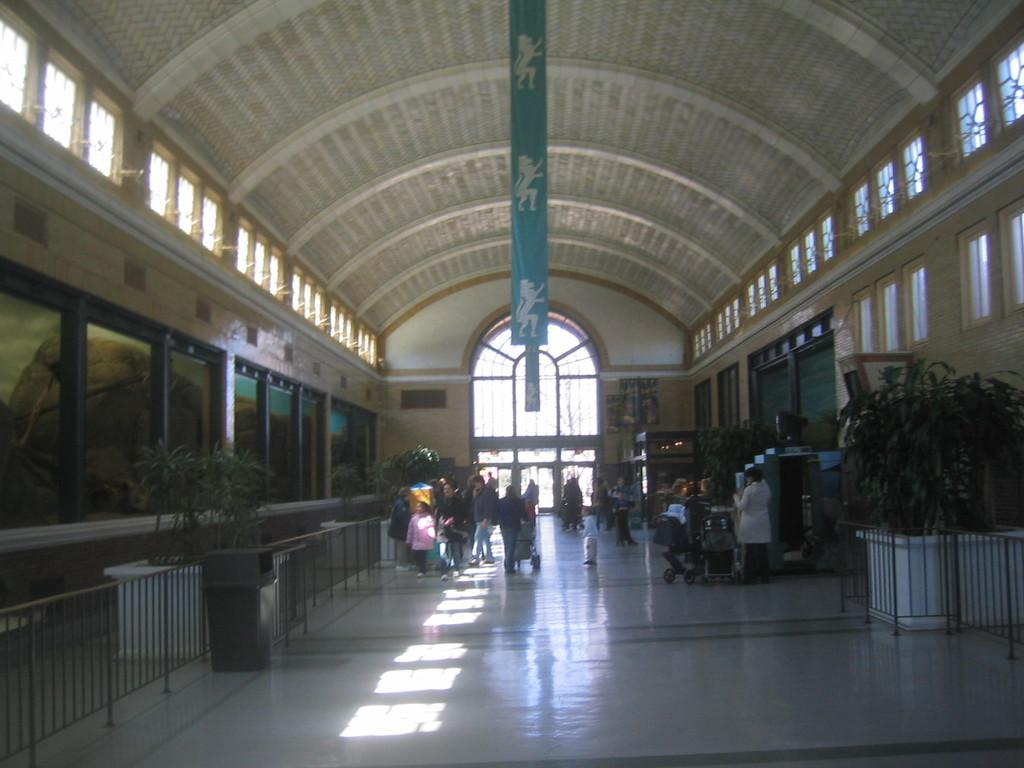What type of structure can be seen in the image? There is a wall in the image. Are there any openings in the wall? Yes, there are windows in the image. What can be found near the wall? There is a dustbin and plants in the image. What is separating the area from another? There is a fence in the image. What is happening in the image involving people? There are people walking in the image. What type of science experiment is being conducted by the tramp in the image? There is no tramp or science experiment present in the image. 